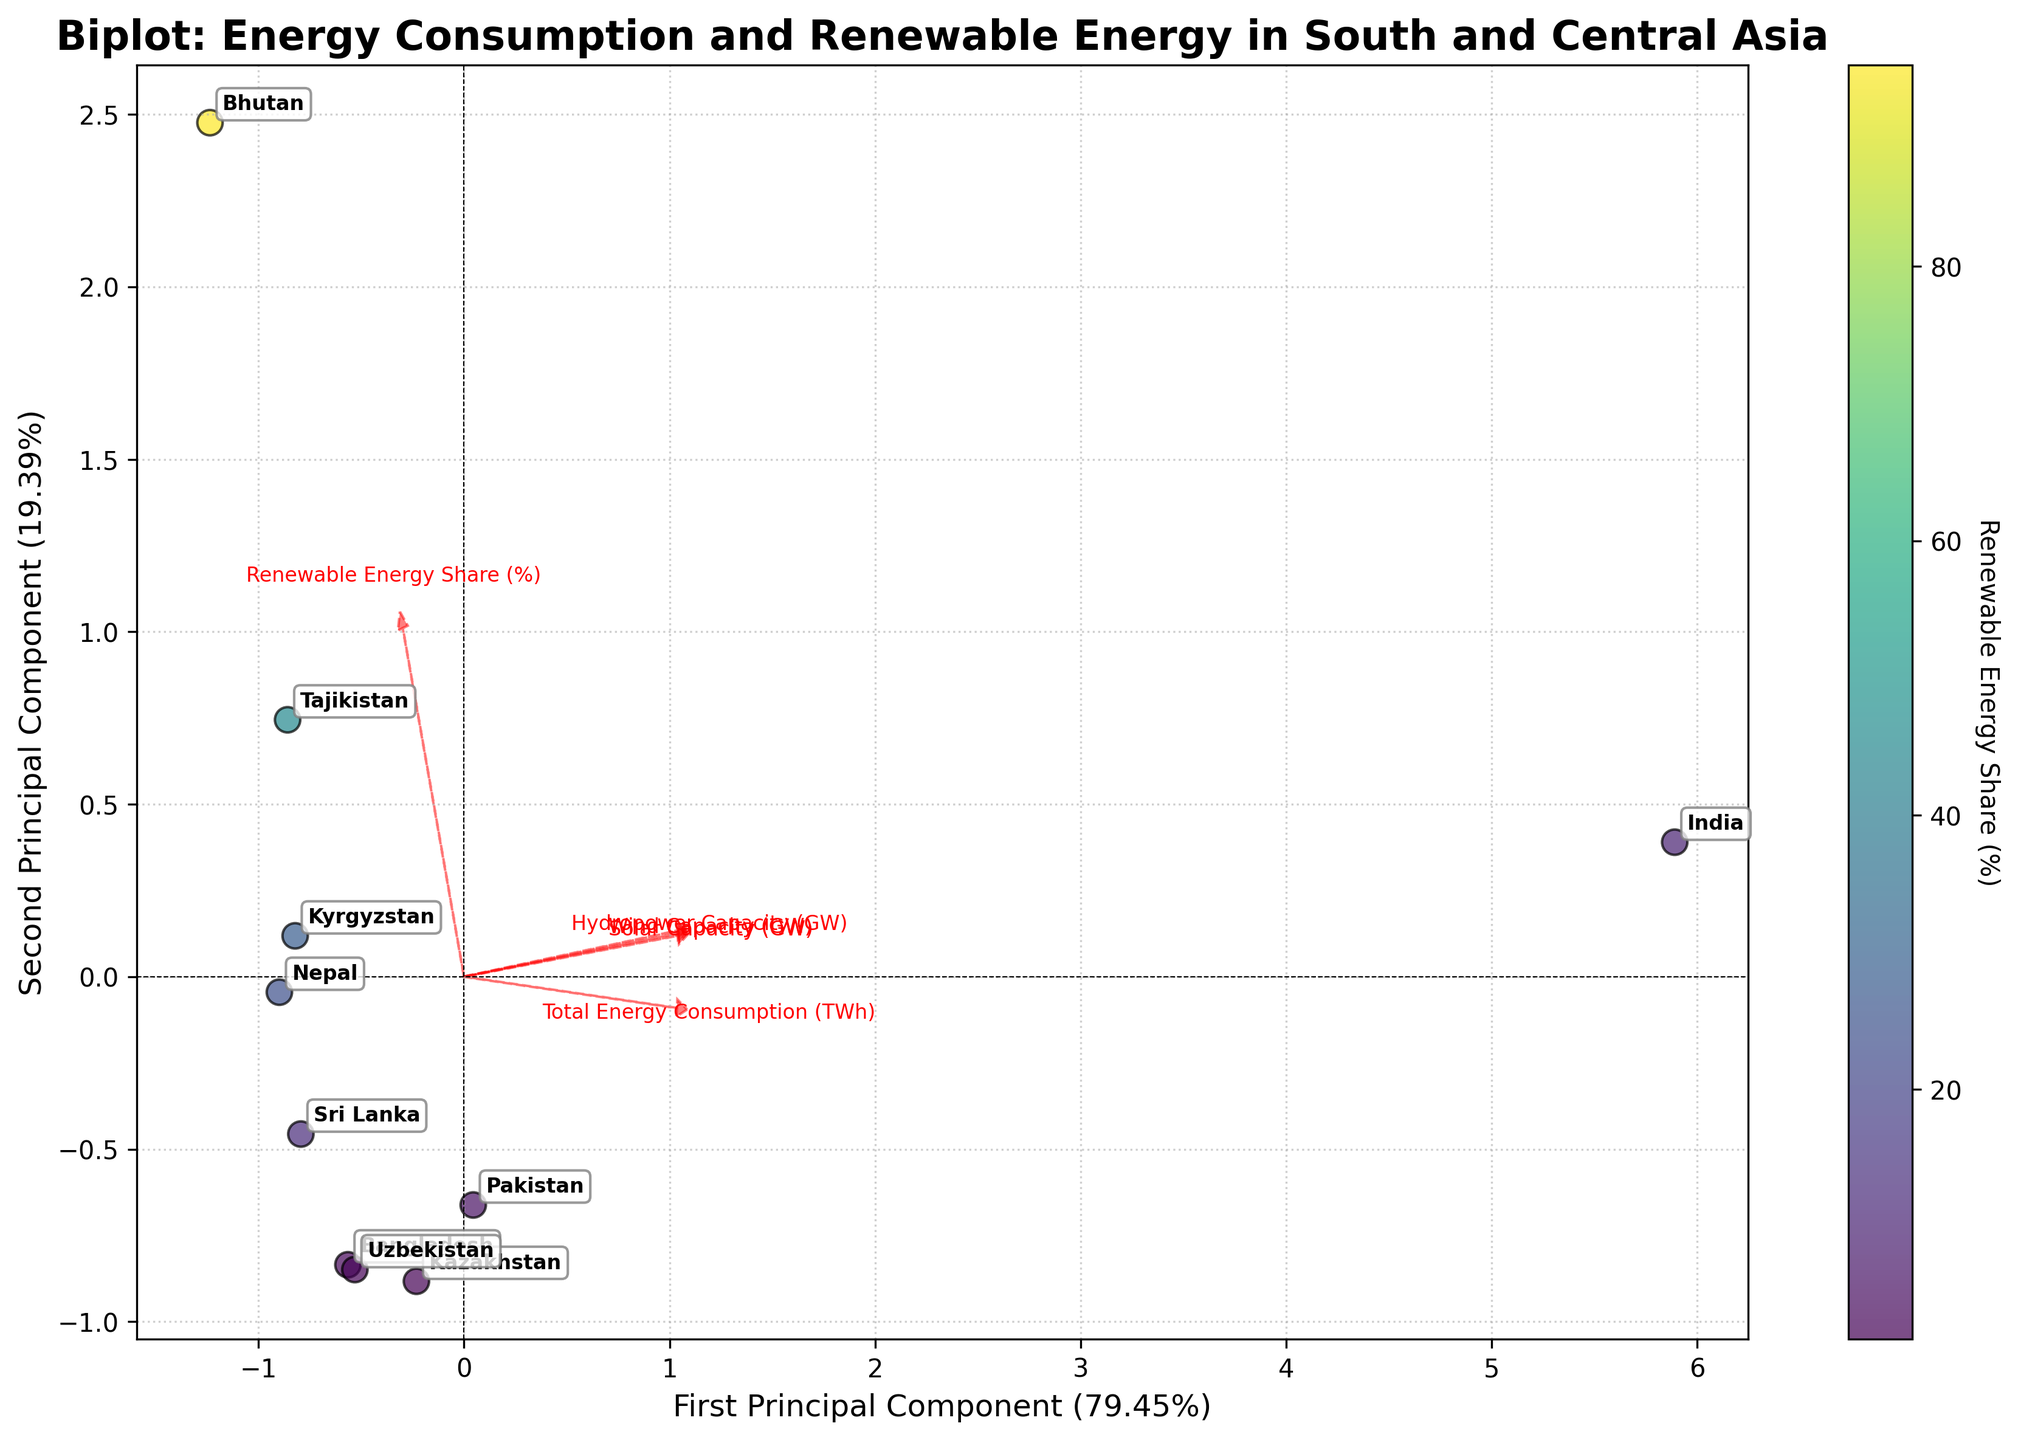What is the title of the figure? The title of the figure can be found at the top. It is written in a bold font and typically summarizes what the figure is about.
Answer: Biplot: Energy Consumption and Renewable Energy in South and Central Asia How is the x-axis labeled in the figure? The x-axis label is typically found at the bottom of the plot and tells us what the x-axis represents. Here, it indicates the first principal component and the variance it explains.
Answer: First Principal Component Which country has the highest Renewable Energy Share (%) based on the figure? To find the country with the highest Renewable Energy Share, look at the color gradient or the color bar indicating Renewable Energy Share (%). The country with the most saturated corresponding color has the highest share.
Answer: Bhutan Which feature has the largest loading on the first principal component? Loading vectors for each feature are represented as arrows. The feature with the longest arrow in the horizontal direction has the largest loading on the first principal component.
Answer: Total Energy Consumption (TWh) Is there any country that seems to have a high Renewable Energy Share (%) but low Total Energy Consumption (TWh)? Look for data points with a strong color indicating high Renewable Energy Share and check their coordinates to identify if they lie towards the lower end of the horizontal axis representing low Total Energy Consumption.
Answer: Bhutan Which two countries are closest to each other on the biplot? To find this, compare the distances between the scatter points representing each country. The shortest distance between two points identifies the closest countries.
Answer: Uzbekistan and Nepal Is there any country where Solar Capacity (GW) appears to be a strong influencing factor? Look for the direction and length of the loading vector for Solar Capacity. Countries that lie in the same direction as this arrow, particularly farther from the origin, are more influenced by Solar Capacity.
Answer: India Which principal component explains more variance in the data? Compare the percentages indicated in the axis labels for both principal components. The principal component with the higher percentage explains more variance.
Answer: First Principal Component Which country has the balance between Solar, Wind, and Hydropower capacities based on the biplot? A country with a balanced capacity will be located where the vectors of Solar, Wind, and Hydropower meet closely, indicating similar loadings from these features.
Answer: Sri Lanka Does the second principal component capture more information about renewable energy adoption or total energy consumption? Look at how the arrows (loading vectors) for features related to renewable energy (Renewable Energy Share, Solar, Wind, Hydropower) align with the second principal component axis in comparison to those for total energy consumption.
Answer: Renewable energy adoption 